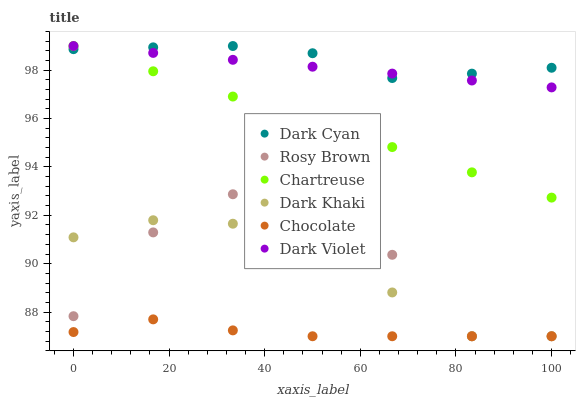Does Chocolate have the minimum area under the curve?
Answer yes or no. Yes. Does Dark Cyan have the maximum area under the curve?
Answer yes or no. Yes. Does Dark Violet have the minimum area under the curve?
Answer yes or no. No. Does Dark Violet have the maximum area under the curve?
Answer yes or no. No. Is Dark Violet the smoothest?
Answer yes or no. Yes. Is Rosy Brown the roughest?
Answer yes or no. Yes. Is Chocolate the smoothest?
Answer yes or no. No. Is Chocolate the roughest?
Answer yes or no. No. Does Rosy Brown have the lowest value?
Answer yes or no. Yes. Does Dark Violet have the lowest value?
Answer yes or no. No. Does Dark Cyan have the highest value?
Answer yes or no. Yes. Does Chocolate have the highest value?
Answer yes or no. No. Is Dark Khaki less than Dark Violet?
Answer yes or no. Yes. Is Chartreuse greater than Chocolate?
Answer yes or no. Yes. Does Dark Cyan intersect Dark Violet?
Answer yes or no. Yes. Is Dark Cyan less than Dark Violet?
Answer yes or no. No. Is Dark Cyan greater than Dark Violet?
Answer yes or no. No. Does Dark Khaki intersect Dark Violet?
Answer yes or no. No. 